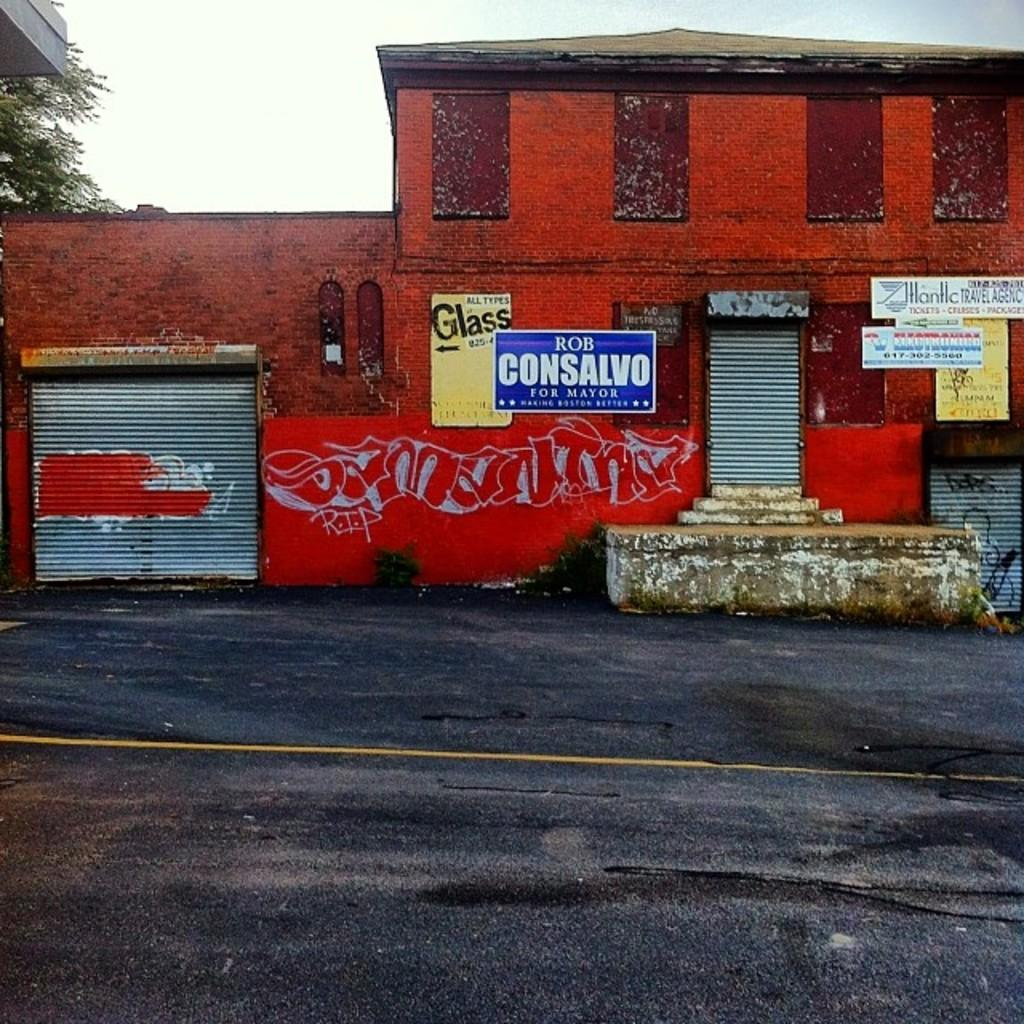What type of structures can be seen in the image? There are buildings in the image. What else is present on the buildings in the image? There are posters on the buildings. What type of barrier is visible in the image? There is a rolling shutter in the image. What type of vegetation is present in the image? There is a tree in the image. What is visible at the top of the image? The sky is visible at the top of the image. What time of day does the image depict, and is the dad present in the image? The time of day is not mentioned in the image, and there is no mention of a dad or any person in the image. What is the wealth status of the people living in the buildings in the image? The wealth status of the people living in the buildings is not mentioned in the image. 